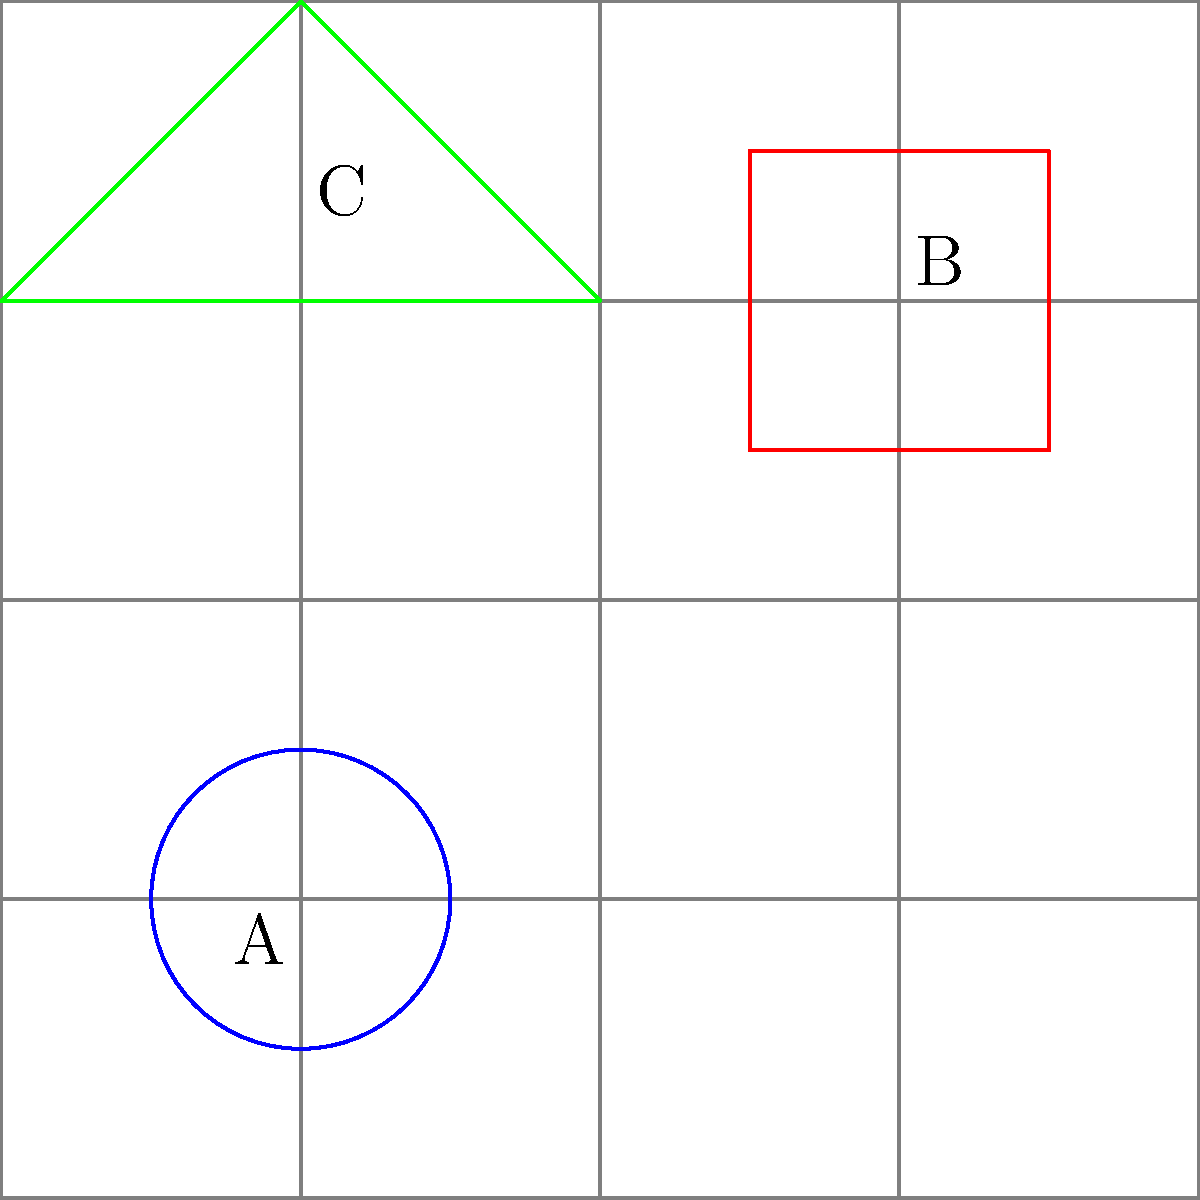In the grid-based logo design shown above, three elements (A, B, and C) are positioned using a 4x4 grid system. If the logo needs to be scaled down to fit within a 100x100 pixel square while maintaining its proportions, what would be the new dimensions (in pixels) of element B? To solve this problem, we need to follow these steps:

1. Understand the current grid system:
   - The logo is designed on a 4x4 grid.
   - Element B (the red square) occupies 1x1 unit of the grid.

2. Calculate the scale factor:
   - The original grid is 4x4 units.
   - The new size is 100x100 pixels.
   - Scale factor = 100 pixels / 4 units = 25 pixels per unit.

3. Determine the size of element B in the original grid:
   - Element B occupies 1x1 unit of the grid.

4. Calculate the new dimensions of element B:
   - New width = 1 unit * 25 pixels/unit = 25 pixels
   - New height = 1 unit * 25 pixels/unit = 25 pixels

Therefore, when scaled down to fit within a 100x100 pixel square, element B would have dimensions of 25x25 pixels.
Answer: 25x25 pixels 